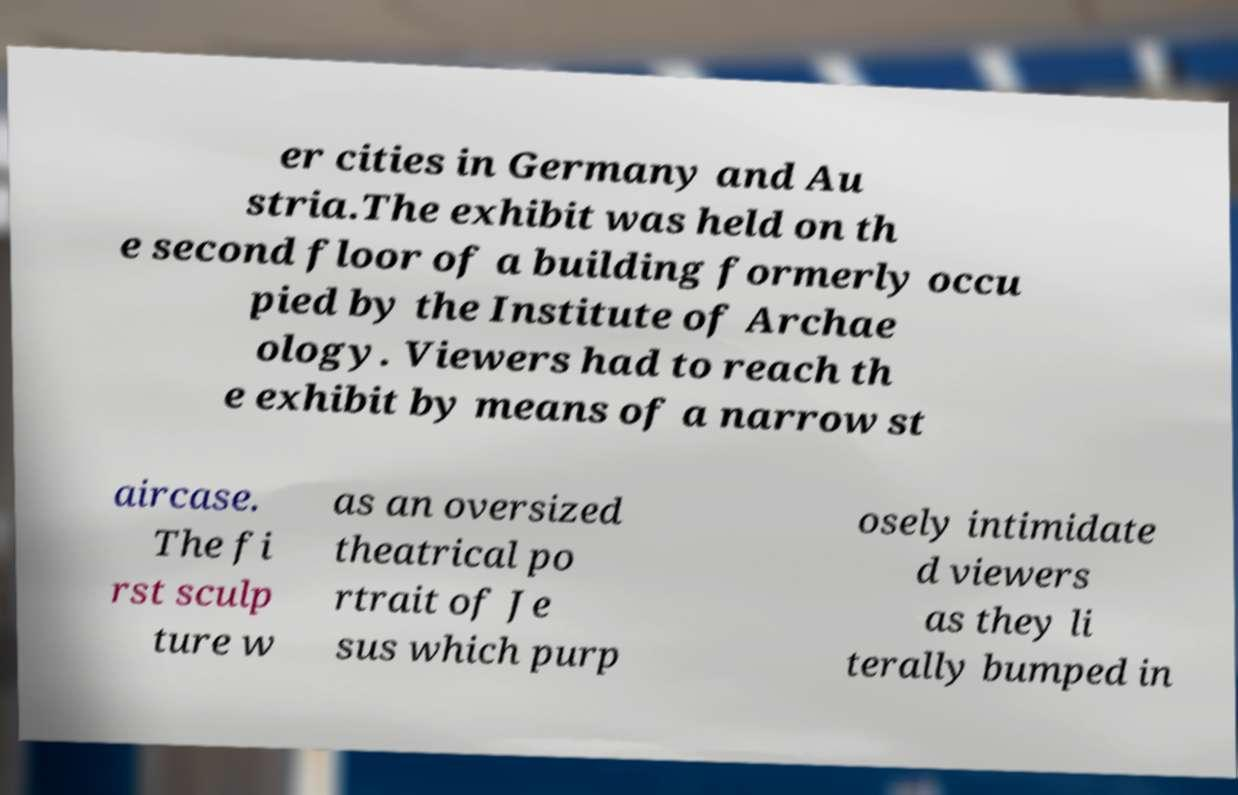Could you assist in decoding the text presented in this image and type it out clearly? er cities in Germany and Au stria.The exhibit was held on th e second floor of a building formerly occu pied by the Institute of Archae ology. Viewers had to reach th e exhibit by means of a narrow st aircase. The fi rst sculp ture w as an oversized theatrical po rtrait of Je sus which purp osely intimidate d viewers as they li terally bumped in 